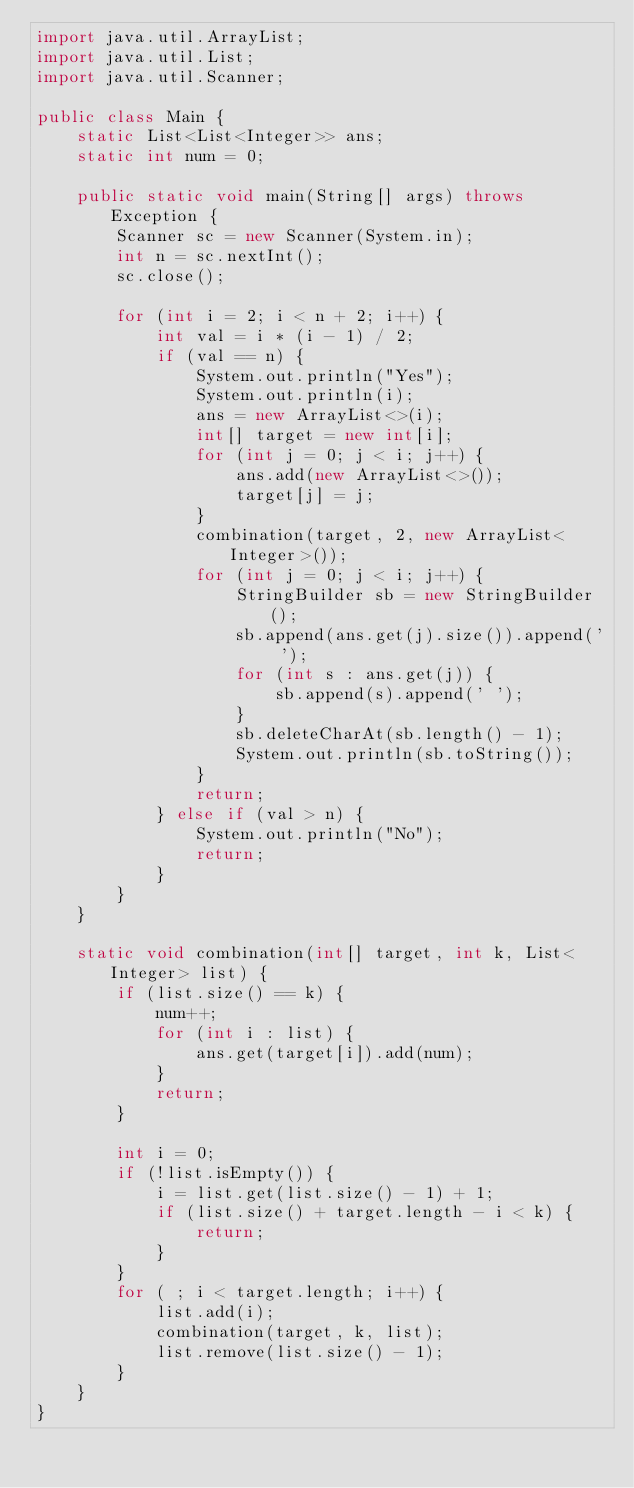<code> <loc_0><loc_0><loc_500><loc_500><_Java_>import java.util.ArrayList;
import java.util.List;
import java.util.Scanner;

public class Main {
	static List<List<Integer>> ans;
	static int num = 0;

	public static void main(String[] args) throws Exception {
		Scanner sc = new Scanner(System.in);
		int n = sc.nextInt();
		sc.close();

		for (int i = 2; i < n + 2; i++) {
			int val = i * (i - 1) / 2;
			if (val == n) {
				System.out.println("Yes");
				System.out.println(i);
				ans = new ArrayList<>(i);
				int[] target = new int[i];
				for (int j = 0; j < i; j++) {
					ans.add(new ArrayList<>());
					target[j] = j;
				}
				combination(target, 2, new ArrayList<Integer>());
				for (int j = 0; j < i; j++) {
					StringBuilder sb = new StringBuilder();
					sb.append(ans.get(j).size()).append(' ');
					for (int s : ans.get(j)) {
						sb.append(s).append(' ');
					}
					sb.deleteCharAt(sb.length() - 1);
					System.out.println(sb.toString());
				}
				return;
			} else if (val > n) {
				System.out.println("No");
				return;
			}
		}
	}

	static void combination(int[] target, int k, List<Integer> list) {
		if (list.size() == k) {
			num++;
			for (int i : list) {
				ans.get(target[i]).add(num);
			}
			return;
		}

		int i = 0;
		if (!list.isEmpty()) {
			i = list.get(list.size() - 1) + 1;
			if (list.size() + target.length - i < k) {
				return;
			}
		}
		for ( ; i < target.length; i++) {
			list.add(i);
			combination(target, k, list);
			list.remove(list.size() - 1);
		}
	}
}
</code> 